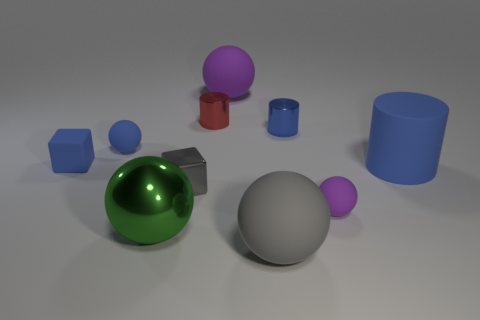Is the gray sphere the same size as the blue matte cylinder?
Offer a terse response. Yes. Are there the same number of matte cubes to the right of the blue cube and small gray blocks that are on the left side of the tiny blue sphere?
Your answer should be very brief. Yes. Is there a large brown rubber cube?
Keep it short and to the point. No. What is the size of the blue matte object that is the same shape as the small purple rubber object?
Make the answer very short. Small. What is the size of the purple matte thing that is behind the big rubber cylinder?
Keep it short and to the point. Large. Is the number of red metallic cylinders to the left of the gray rubber object greater than the number of tiny yellow shiny things?
Make the answer very short. Yes. There is a gray metal object; what shape is it?
Make the answer very short. Cube. Does the tiny ball right of the gray matte sphere have the same color as the large matte object that is behind the big blue thing?
Give a very brief answer. Yes. Does the red metallic thing have the same shape as the blue metallic thing?
Provide a succinct answer. Yes. Do the tiny sphere that is on the right side of the large gray sphere and the tiny blue ball have the same material?
Your response must be concise. Yes. 